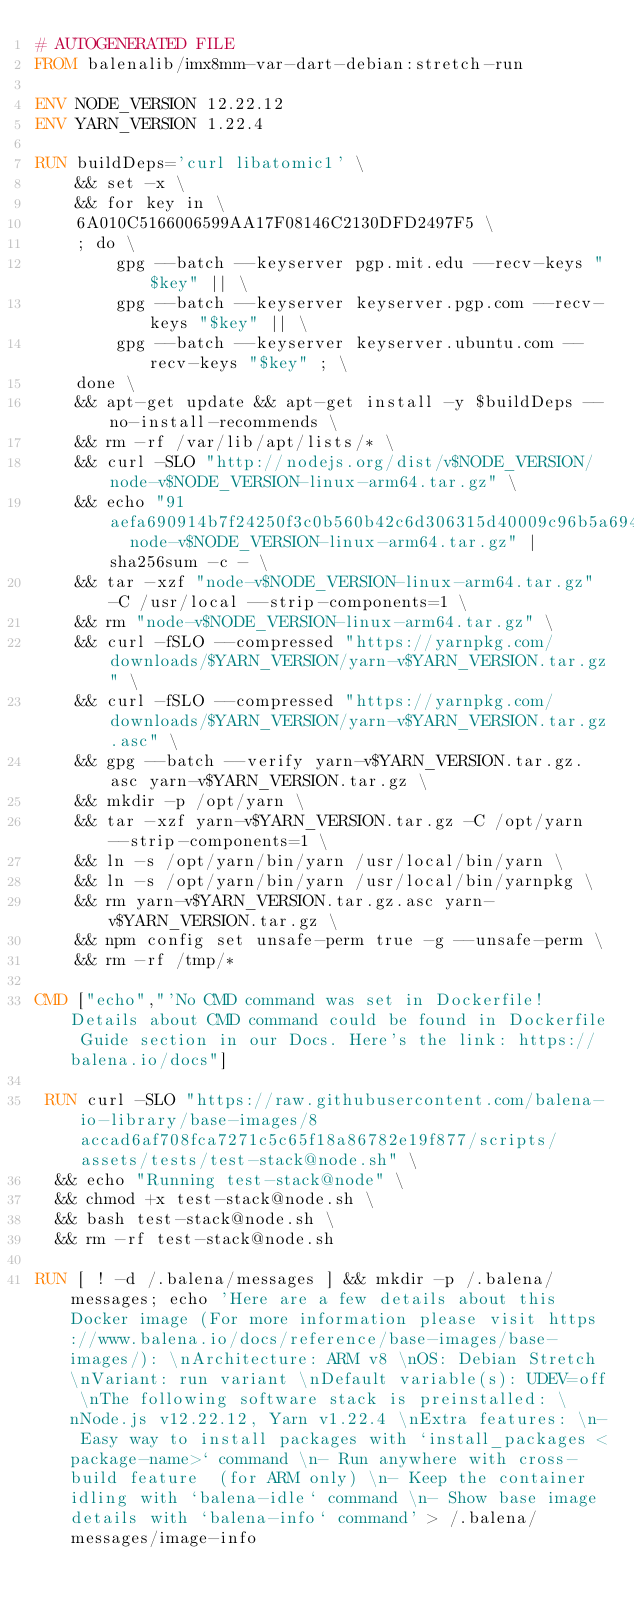<code> <loc_0><loc_0><loc_500><loc_500><_Dockerfile_># AUTOGENERATED FILE
FROM balenalib/imx8mm-var-dart-debian:stretch-run

ENV NODE_VERSION 12.22.12
ENV YARN_VERSION 1.22.4

RUN buildDeps='curl libatomic1' \
	&& set -x \
	&& for key in \
	6A010C5166006599AA17F08146C2130DFD2497F5 \
	; do \
		gpg --batch --keyserver pgp.mit.edu --recv-keys "$key" || \
		gpg --batch --keyserver keyserver.pgp.com --recv-keys "$key" || \
		gpg --batch --keyserver keyserver.ubuntu.com --recv-keys "$key" ; \
	done \
	&& apt-get update && apt-get install -y $buildDeps --no-install-recommends \
	&& rm -rf /var/lib/apt/lists/* \
	&& curl -SLO "http://nodejs.org/dist/v$NODE_VERSION/node-v$NODE_VERSION-linux-arm64.tar.gz" \
	&& echo "91aefa690914b7f24250f3c0b560b42c6d306315d40009c96b5a6940115895fe  node-v$NODE_VERSION-linux-arm64.tar.gz" | sha256sum -c - \
	&& tar -xzf "node-v$NODE_VERSION-linux-arm64.tar.gz" -C /usr/local --strip-components=1 \
	&& rm "node-v$NODE_VERSION-linux-arm64.tar.gz" \
	&& curl -fSLO --compressed "https://yarnpkg.com/downloads/$YARN_VERSION/yarn-v$YARN_VERSION.tar.gz" \
	&& curl -fSLO --compressed "https://yarnpkg.com/downloads/$YARN_VERSION/yarn-v$YARN_VERSION.tar.gz.asc" \
	&& gpg --batch --verify yarn-v$YARN_VERSION.tar.gz.asc yarn-v$YARN_VERSION.tar.gz \
	&& mkdir -p /opt/yarn \
	&& tar -xzf yarn-v$YARN_VERSION.tar.gz -C /opt/yarn --strip-components=1 \
	&& ln -s /opt/yarn/bin/yarn /usr/local/bin/yarn \
	&& ln -s /opt/yarn/bin/yarn /usr/local/bin/yarnpkg \
	&& rm yarn-v$YARN_VERSION.tar.gz.asc yarn-v$YARN_VERSION.tar.gz \
	&& npm config set unsafe-perm true -g --unsafe-perm \
	&& rm -rf /tmp/*

CMD ["echo","'No CMD command was set in Dockerfile! Details about CMD command could be found in Dockerfile Guide section in our Docs. Here's the link: https://balena.io/docs"]

 RUN curl -SLO "https://raw.githubusercontent.com/balena-io-library/base-images/8accad6af708fca7271c5c65f18a86782e19f877/scripts/assets/tests/test-stack@node.sh" \
  && echo "Running test-stack@node" \
  && chmod +x test-stack@node.sh \
  && bash test-stack@node.sh \
  && rm -rf test-stack@node.sh 

RUN [ ! -d /.balena/messages ] && mkdir -p /.balena/messages; echo 'Here are a few details about this Docker image (For more information please visit https://www.balena.io/docs/reference/base-images/base-images/): \nArchitecture: ARM v8 \nOS: Debian Stretch \nVariant: run variant \nDefault variable(s): UDEV=off \nThe following software stack is preinstalled: \nNode.js v12.22.12, Yarn v1.22.4 \nExtra features: \n- Easy way to install packages with `install_packages <package-name>` command \n- Run anywhere with cross-build feature  (for ARM only) \n- Keep the container idling with `balena-idle` command \n- Show base image details with `balena-info` command' > /.balena/messages/image-info</code> 